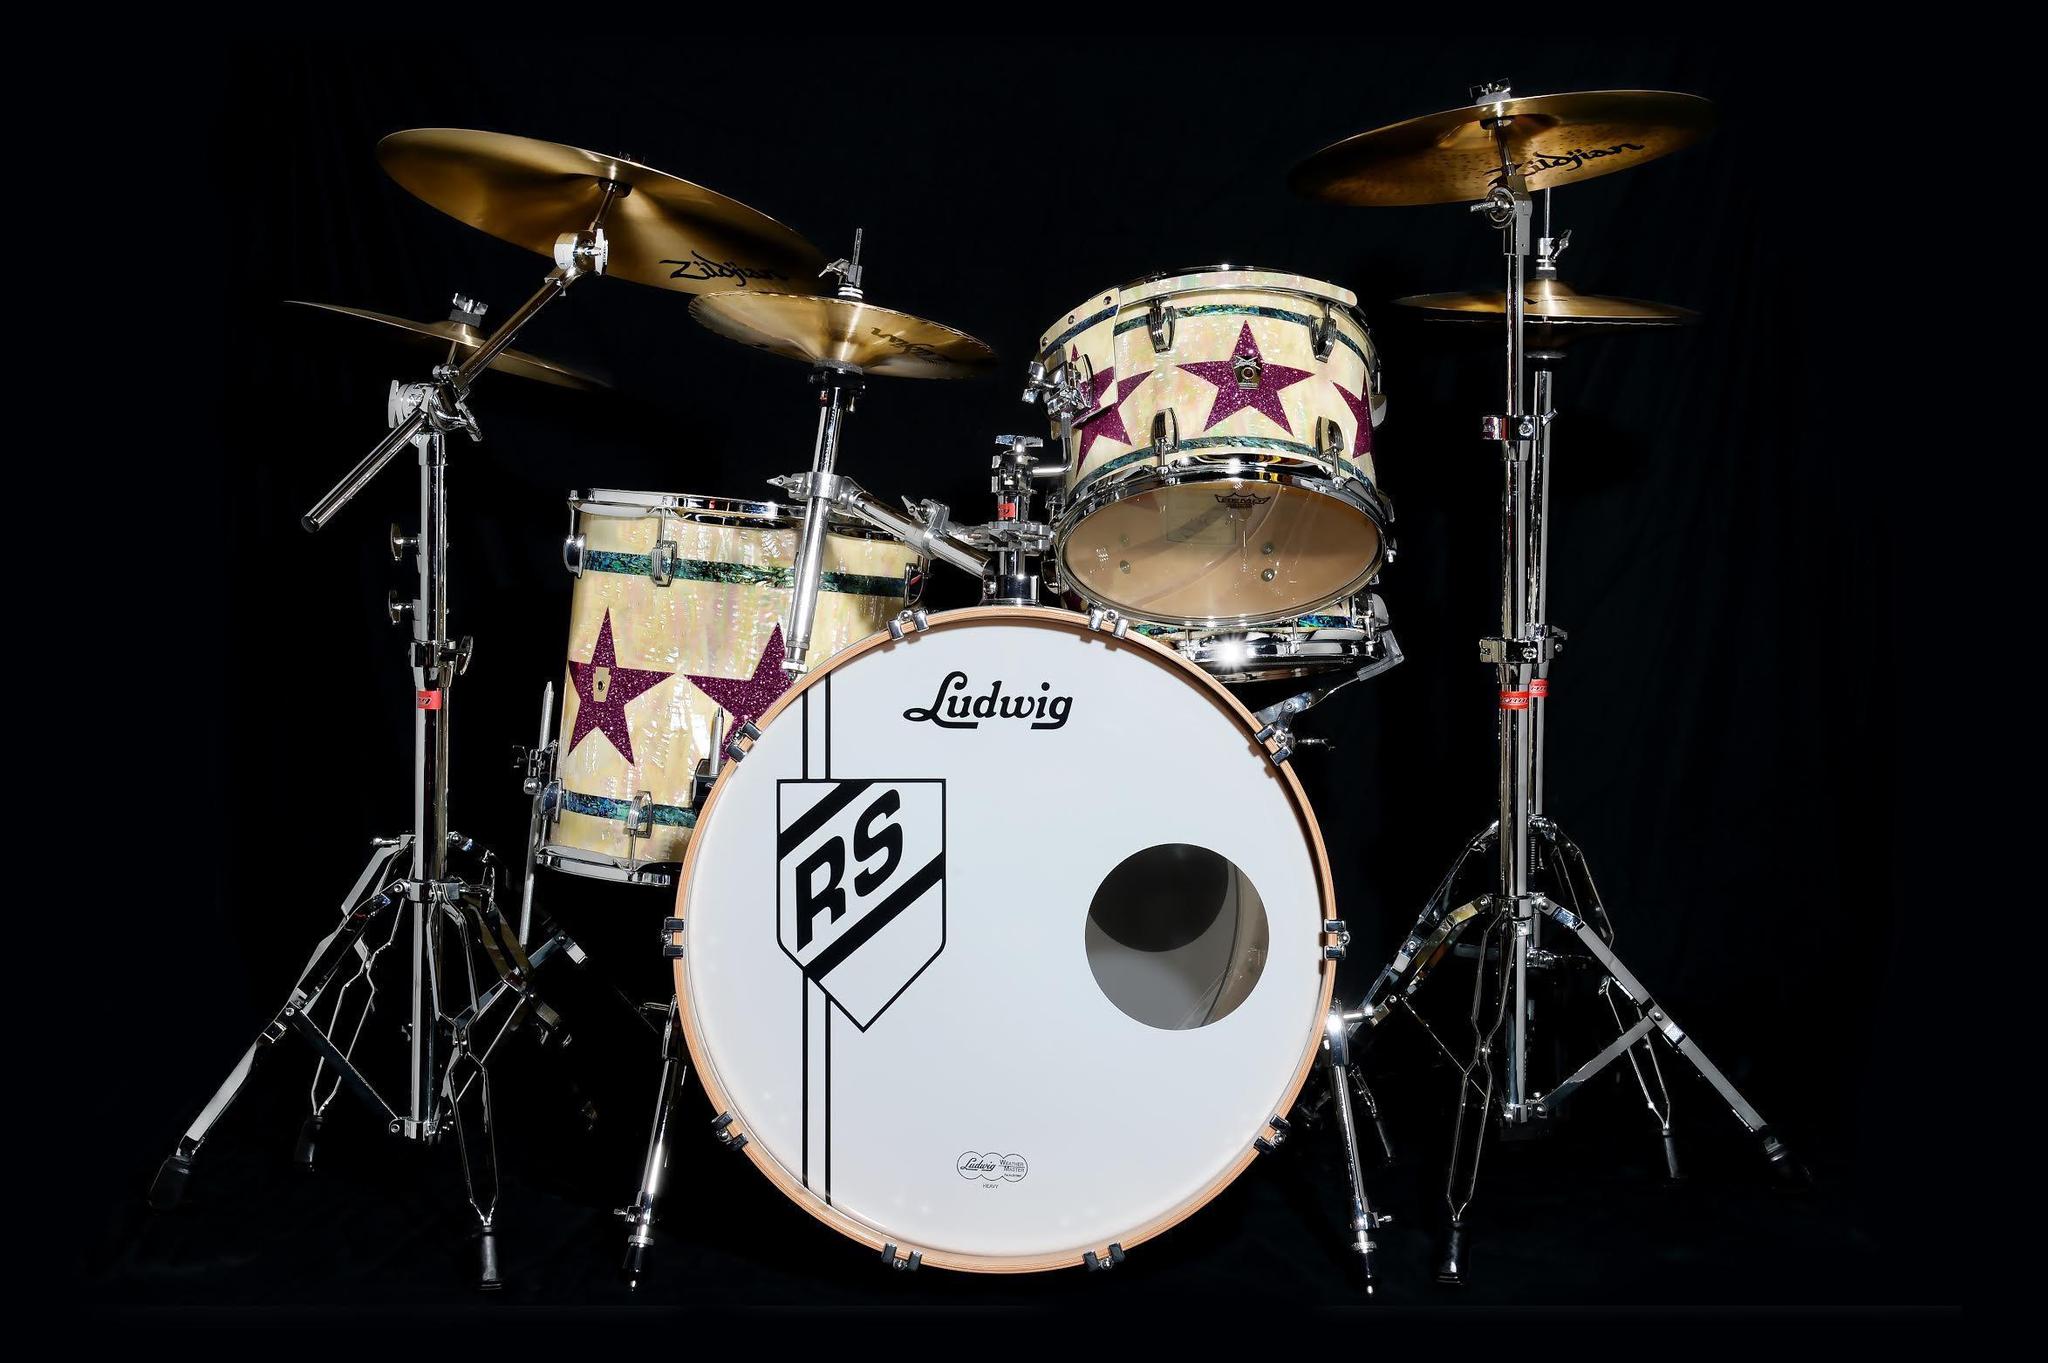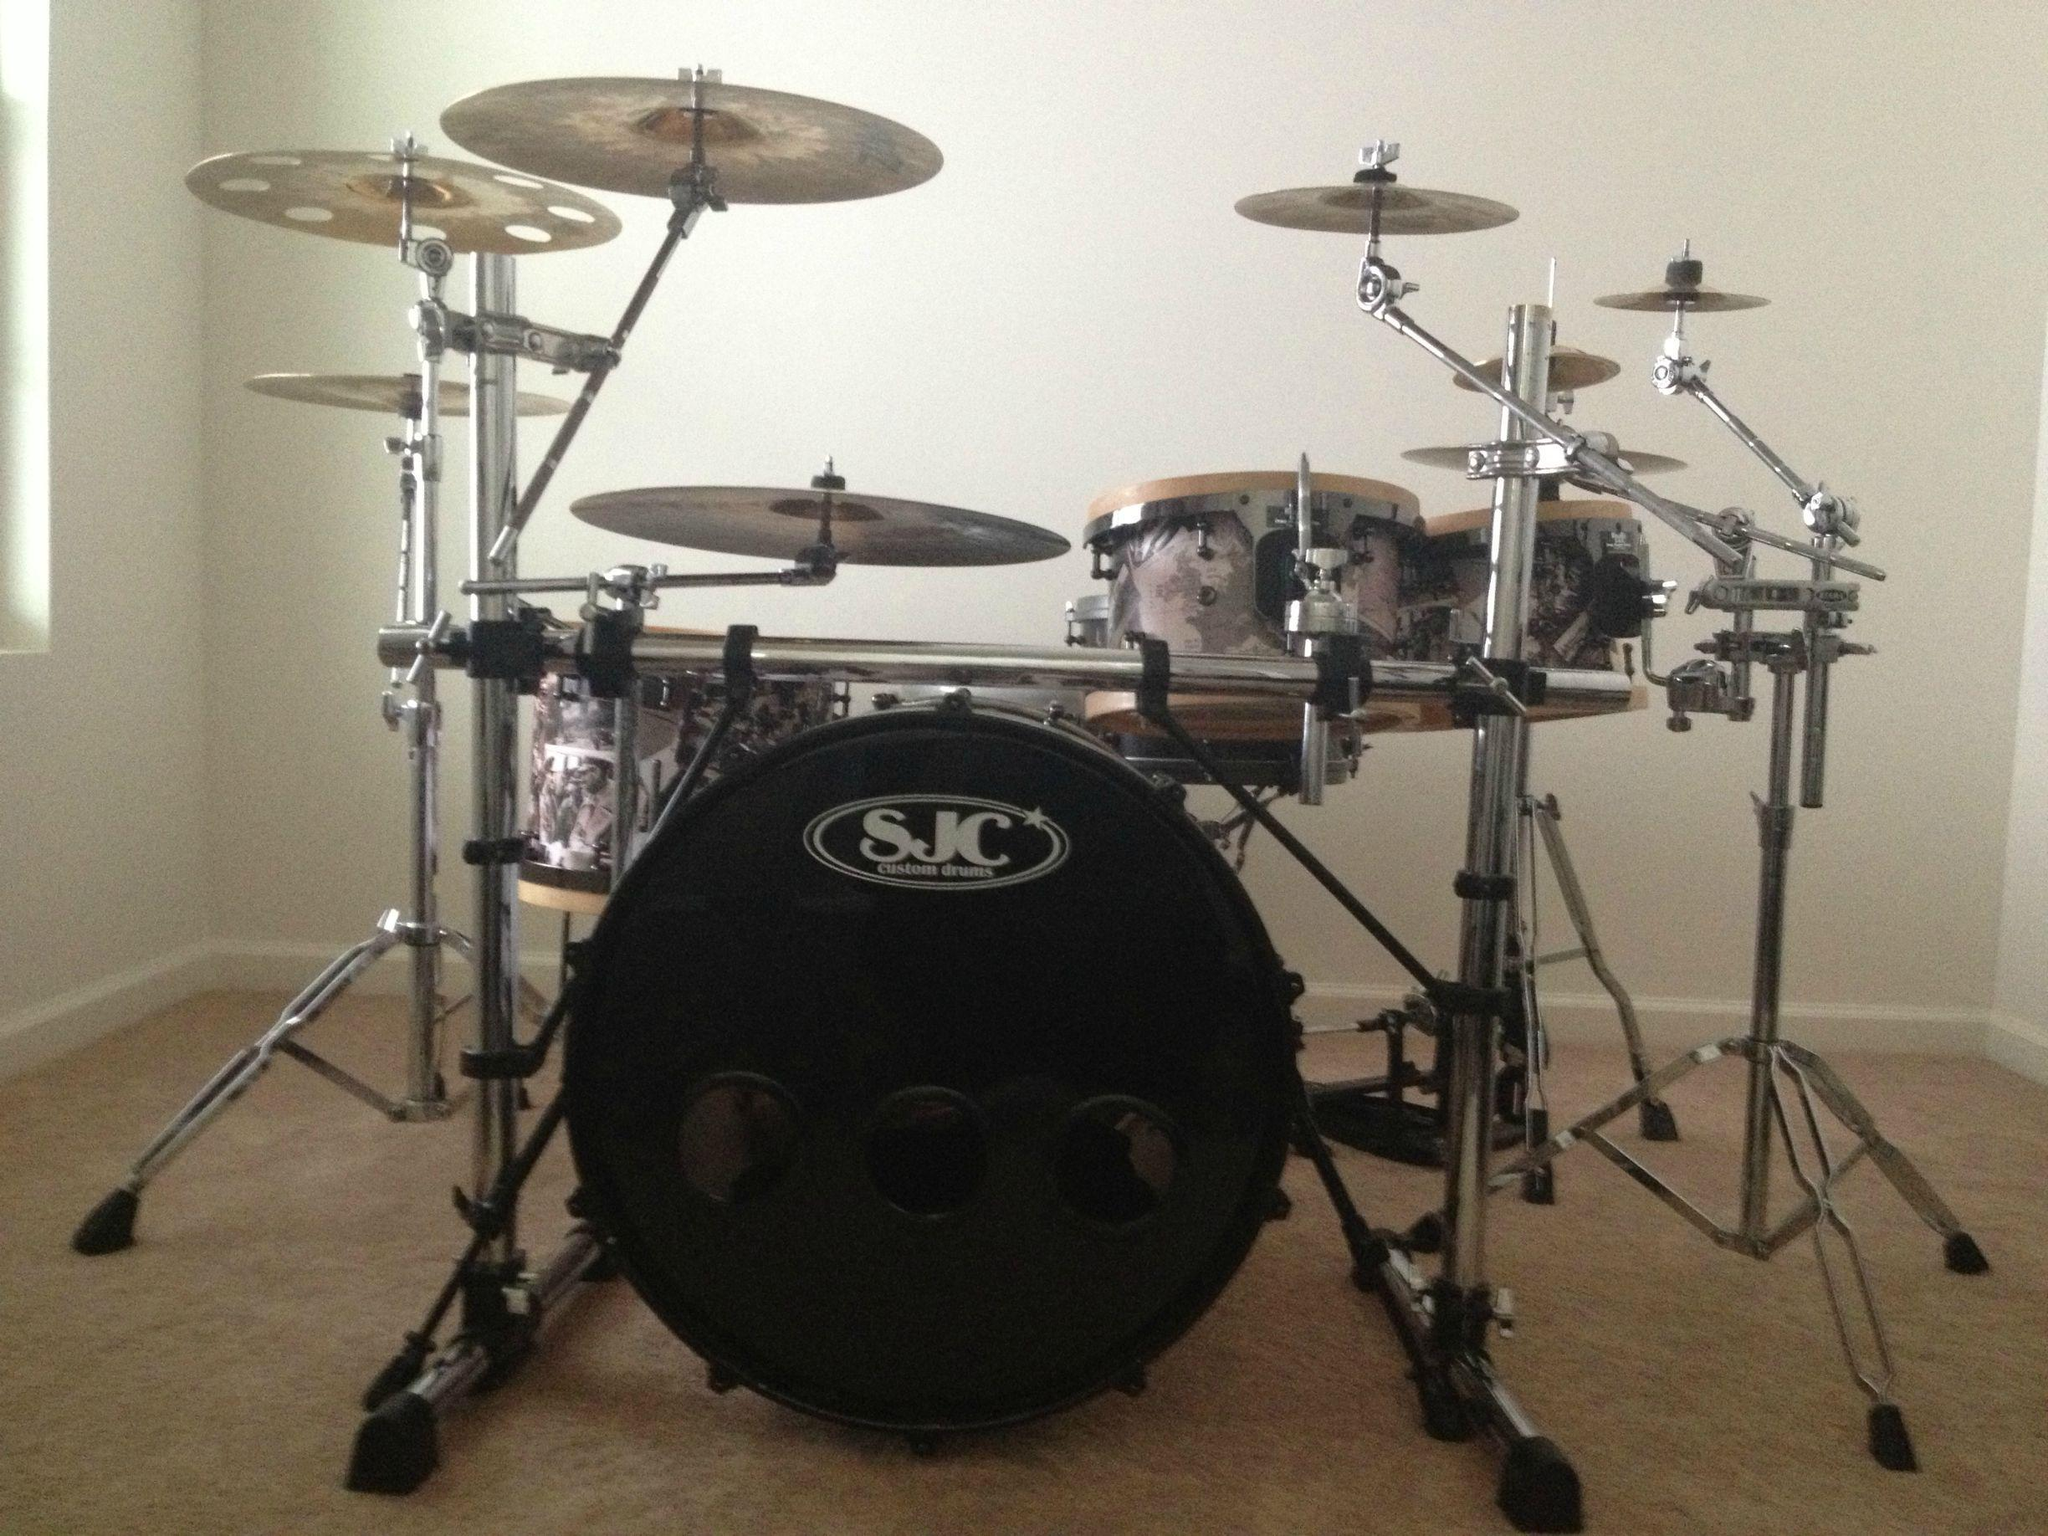The first image is the image on the left, the second image is the image on the right. Assess this claim about the two images: "One image features a drum kit with the central large drum showing a black round side, and the other image features a drum kit with the central large drum showing a round white side.". Correct or not? Answer yes or no. Yes. The first image is the image on the left, the second image is the image on the right. Evaluate the accuracy of this statement regarding the images: "The kick drum skin in the left image is black.". Is it true? Answer yes or no. No. 